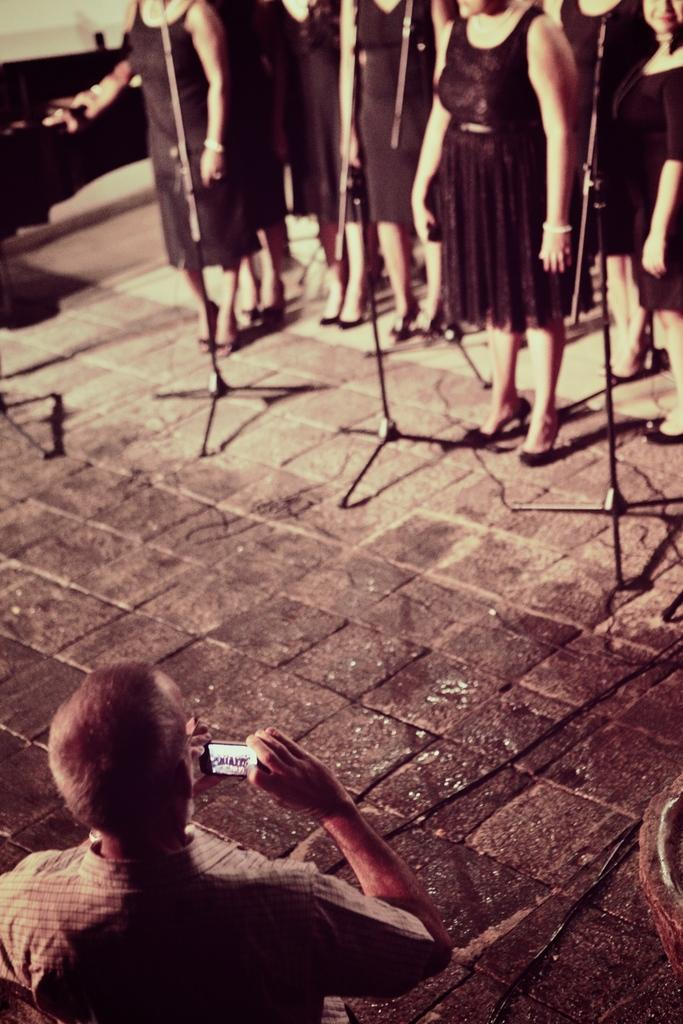What objects can be seen in the foreground of the image? There are three tripod stands in the foreground of the image. What are the women in the image doing? The women are standing in front of the tripod stands. Can you describe the man's position and activity in the image? There is a man holding a camera in his hand in the bottom left corner of the image. What type of coil is being used to control the tripod stands in the image? There is no coil or control mechanism visible for the tripod stands in the image; they are stationary. 